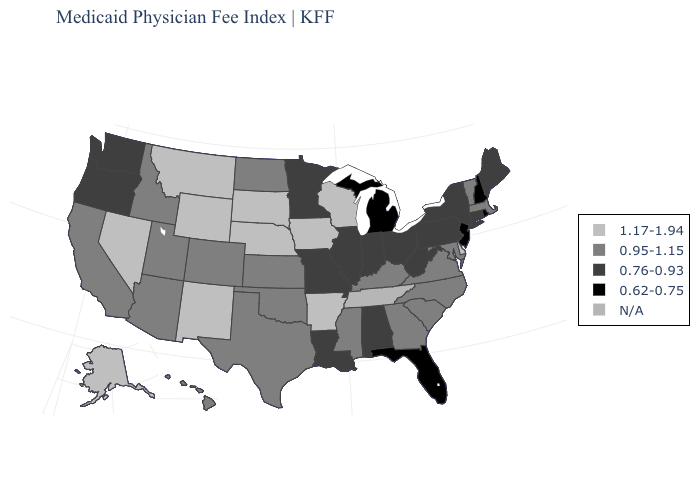Name the states that have a value in the range N/A?
Be succinct. Tennessee. How many symbols are there in the legend?
Be succinct. 5. Name the states that have a value in the range N/A?
Write a very short answer. Tennessee. Name the states that have a value in the range N/A?
Answer briefly. Tennessee. What is the lowest value in the Northeast?
Quick response, please. 0.62-0.75. Name the states that have a value in the range N/A?
Concise answer only. Tennessee. Does the first symbol in the legend represent the smallest category?
Answer briefly. No. Does Utah have the highest value in the USA?
Write a very short answer. No. Is the legend a continuous bar?
Keep it brief. No. What is the highest value in states that border Massachusetts?
Quick response, please. 0.95-1.15. Does New York have the highest value in the Northeast?
Be succinct. No. What is the value of Washington?
Quick response, please. 0.76-0.93. Which states hav the highest value in the MidWest?
Concise answer only. Iowa, Nebraska, South Dakota, Wisconsin. Which states have the lowest value in the West?
Short answer required. Oregon, Washington. What is the value of Kansas?
Answer briefly. 0.95-1.15. 